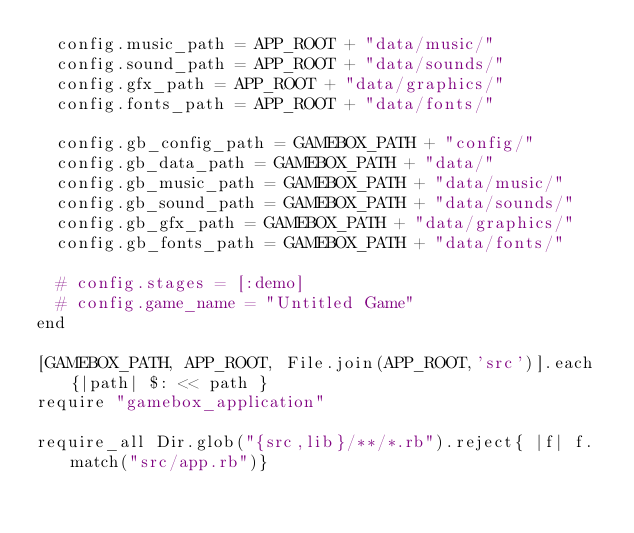<code> <loc_0><loc_0><loc_500><loc_500><_Ruby_>  config.music_path = APP_ROOT + "data/music/"
  config.sound_path = APP_ROOT + "data/sounds/"
  config.gfx_path = APP_ROOT + "data/graphics/"
  config.fonts_path = APP_ROOT + "data/fonts/"

  config.gb_config_path = GAMEBOX_PATH + "config/"
  config.gb_data_path = GAMEBOX_PATH + "data/"
  config.gb_music_path = GAMEBOX_PATH + "data/music/"
  config.gb_sound_path = GAMEBOX_PATH + "data/sounds/"
  config.gb_gfx_path = GAMEBOX_PATH + "data/graphics/"
  config.gb_fonts_path = GAMEBOX_PATH + "data/fonts/"
  
  # config.stages = [:demo]
  # config.game_name = "Untitled Game"
end

[GAMEBOX_PATH, APP_ROOT, File.join(APP_ROOT,'src')].each{|path| $: << path }
require "gamebox_application"

require_all Dir.glob("{src,lib}/**/*.rb").reject{ |f| f.match("src/app.rb")}



</code> 